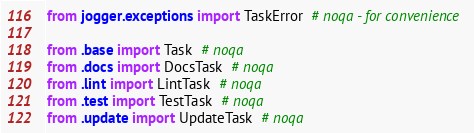Convert code to text. <code><loc_0><loc_0><loc_500><loc_500><_Python_>from jogger.exceptions import TaskError  # noqa - for convenience

from .base import Task  # noqa
from .docs import DocsTask  # noqa
from .lint import LintTask  # noqa
from .test import TestTask  # noqa
from .update import UpdateTask  # noqa
</code> 